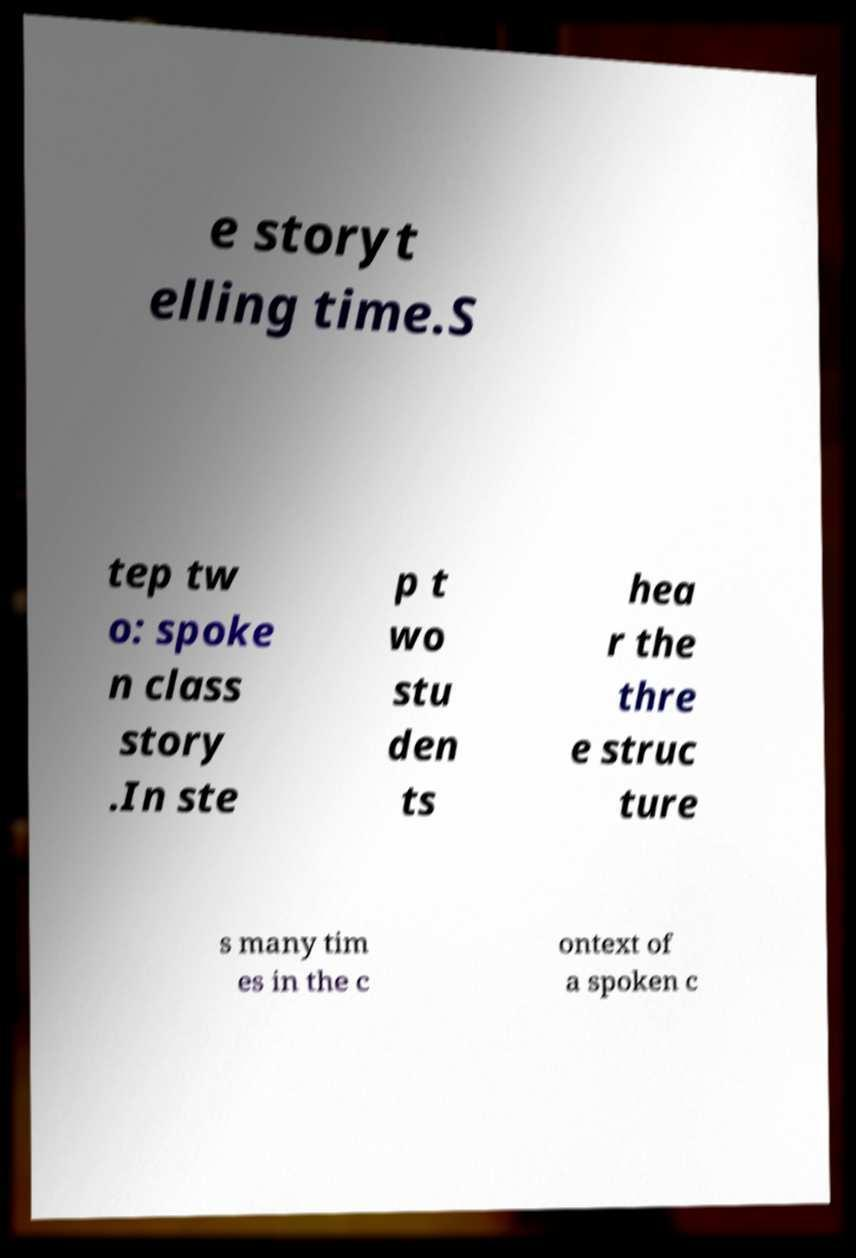For documentation purposes, I need the text within this image transcribed. Could you provide that? e storyt elling time.S tep tw o: spoke n class story .In ste p t wo stu den ts hea r the thre e struc ture s many tim es in the c ontext of a spoken c 